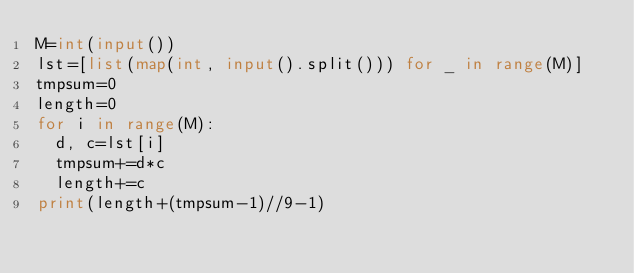<code> <loc_0><loc_0><loc_500><loc_500><_Python_>M=int(input())
lst=[list(map(int, input().split())) for _ in range(M)]
tmpsum=0
length=0
for i in range(M):
  d, c=lst[i]
  tmpsum+=d*c
  length+=c
print(length+(tmpsum-1)//9-1)</code> 